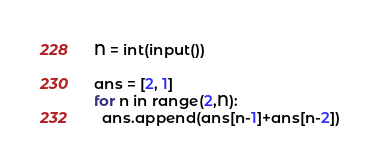<code> <loc_0><loc_0><loc_500><loc_500><_Python_>N = int(input())

ans = [2, 1]
for n in range(2,N):
  ans.append(ans[n-1]+ans[n-2])</code> 